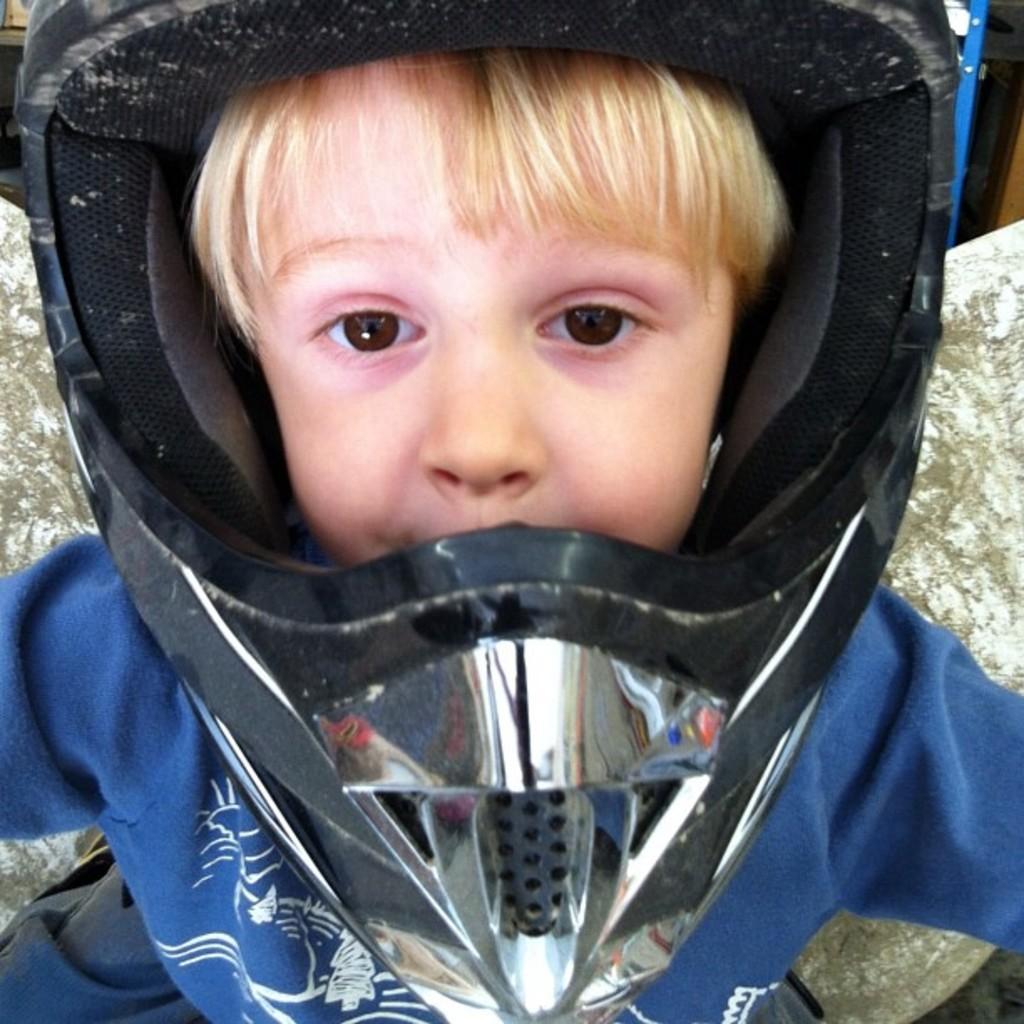Could you give a brief overview of what you see in this image? In the image there is a baby with blue dress and keep helmet on his head. 